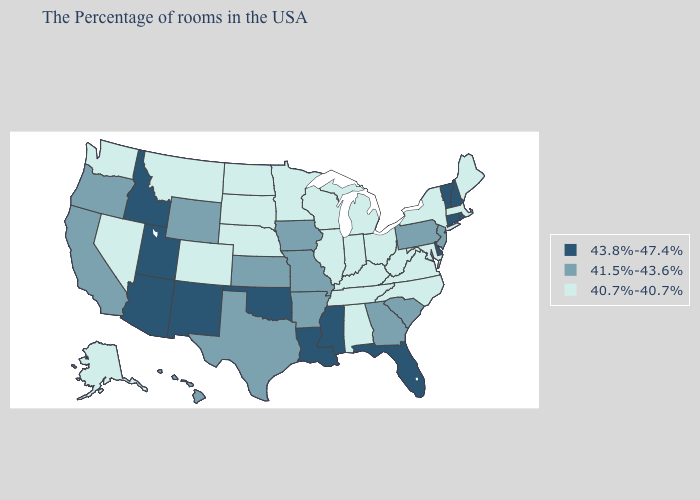Does Nevada have the highest value in the West?
Keep it brief. No. What is the value of Georgia?
Short answer required. 41.5%-43.6%. Name the states that have a value in the range 41.5%-43.6%?
Concise answer only. New Jersey, Pennsylvania, South Carolina, Georgia, Missouri, Arkansas, Iowa, Kansas, Texas, Wyoming, California, Oregon, Hawaii. Does the first symbol in the legend represent the smallest category?
Short answer required. No. Which states have the highest value in the USA?
Give a very brief answer. Rhode Island, New Hampshire, Vermont, Connecticut, Delaware, Florida, Mississippi, Louisiana, Oklahoma, New Mexico, Utah, Arizona, Idaho. What is the highest value in the USA?
Give a very brief answer. 43.8%-47.4%. Which states hav the highest value in the West?
Short answer required. New Mexico, Utah, Arizona, Idaho. Which states have the highest value in the USA?
Give a very brief answer. Rhode Island, New Hampshire, Vermont, Connecticut, Delaware, Florida, Mississippi, Louisiana, Oklahoma, New Mexico, Utah, Arizona, Idaho. Does the map have missing data?
Keep it brief. No. Does the map have missing data?
Quick response, please. No. What is the value of Oregon?
Be succinct. 41.5%-43.6%. Name the states that have a value in the range 41.5%-43.6%?
Quick response, please. New Jersey, Pennsylvania, South Carolina, Georgia, Missouri, Arkansas, Iowa, Kansas, Texas, Wyoming, California, Oregon, Hawaii. Among the states that border Alabama , which have the highest value?
Quick response, please. Florida, Mississippi. Name the states that have a value in the range 43.8%-47.4%?
Give a very brief answer. Rhode Island, New Hampshire, Vermont, Connecticut, Delaware, Florida, Mississippi, Louisiana, Oklahoma, New Mexico, Utah, Arizona, Idaho. 